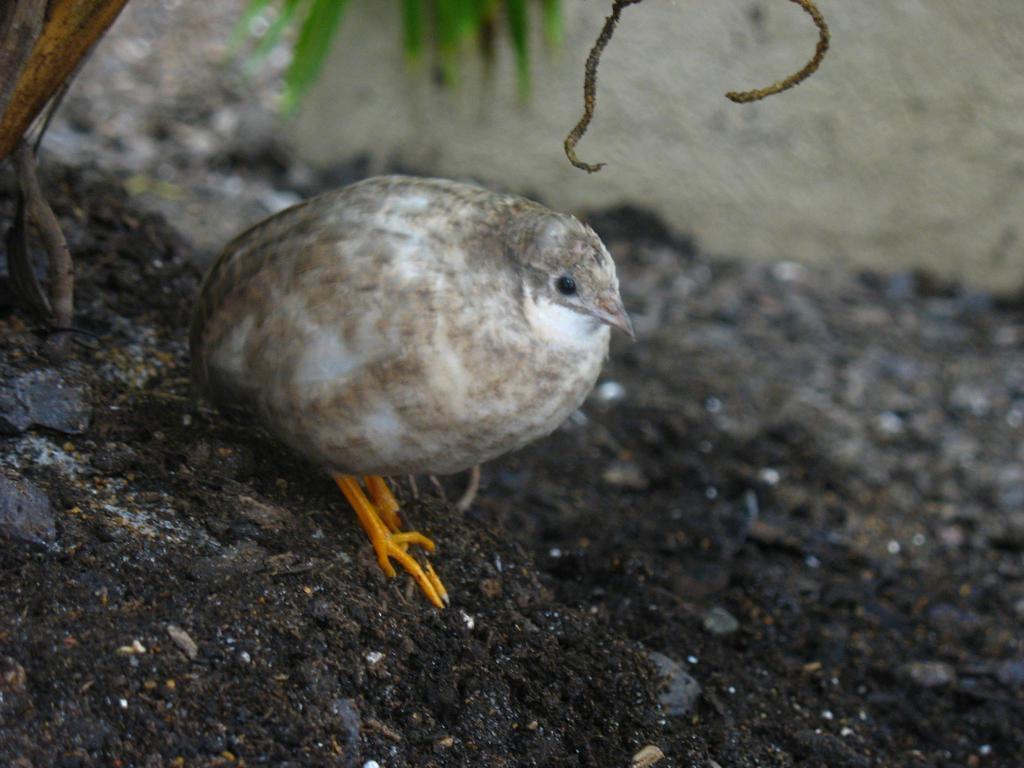How would you summarize this image in a sentence or two? This image is taken outdoors. At the bottom of the image there is a ground. In the middle of the image there is a bird on the ground. In the background there is a wall. At the top left of the image there is a plant. 